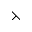<formula> <loc_0><loc_0><loc_500><loc_500>\left t h r e e t i m e s</formula> 